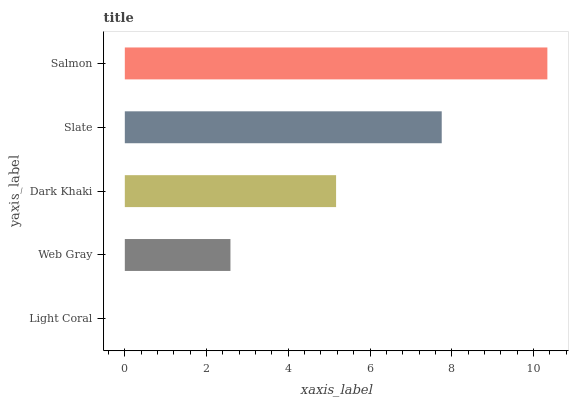Is Light Coral the minimum?
Answer yes or no. Yes. Is Salmon the maximum?
Answer yes or no. Yes. Is Web Gray the minimum?
Answer yes or no. No. Is Web Gray the maximum?
Answer yes or no. No. Is Web Gray greater than Light Coral?
Answer yes or no. Yes. Is Light Coral less than Web Gray?
Answer yes or no. Yes. Is Light Coral greater than Web Gray?
Answer yes or no. No. Is Web Gray less than Light Coral?
Answer yes or no. No. Is Dark Khaki the high median?
Answer yes or no. Yes. Is Dark Khaki the low median?
Answer yes or no. Yes. Is Slate the high median?
Answer yes or no. No. Is Light Coral the low median?
Answer yes or no. No. 